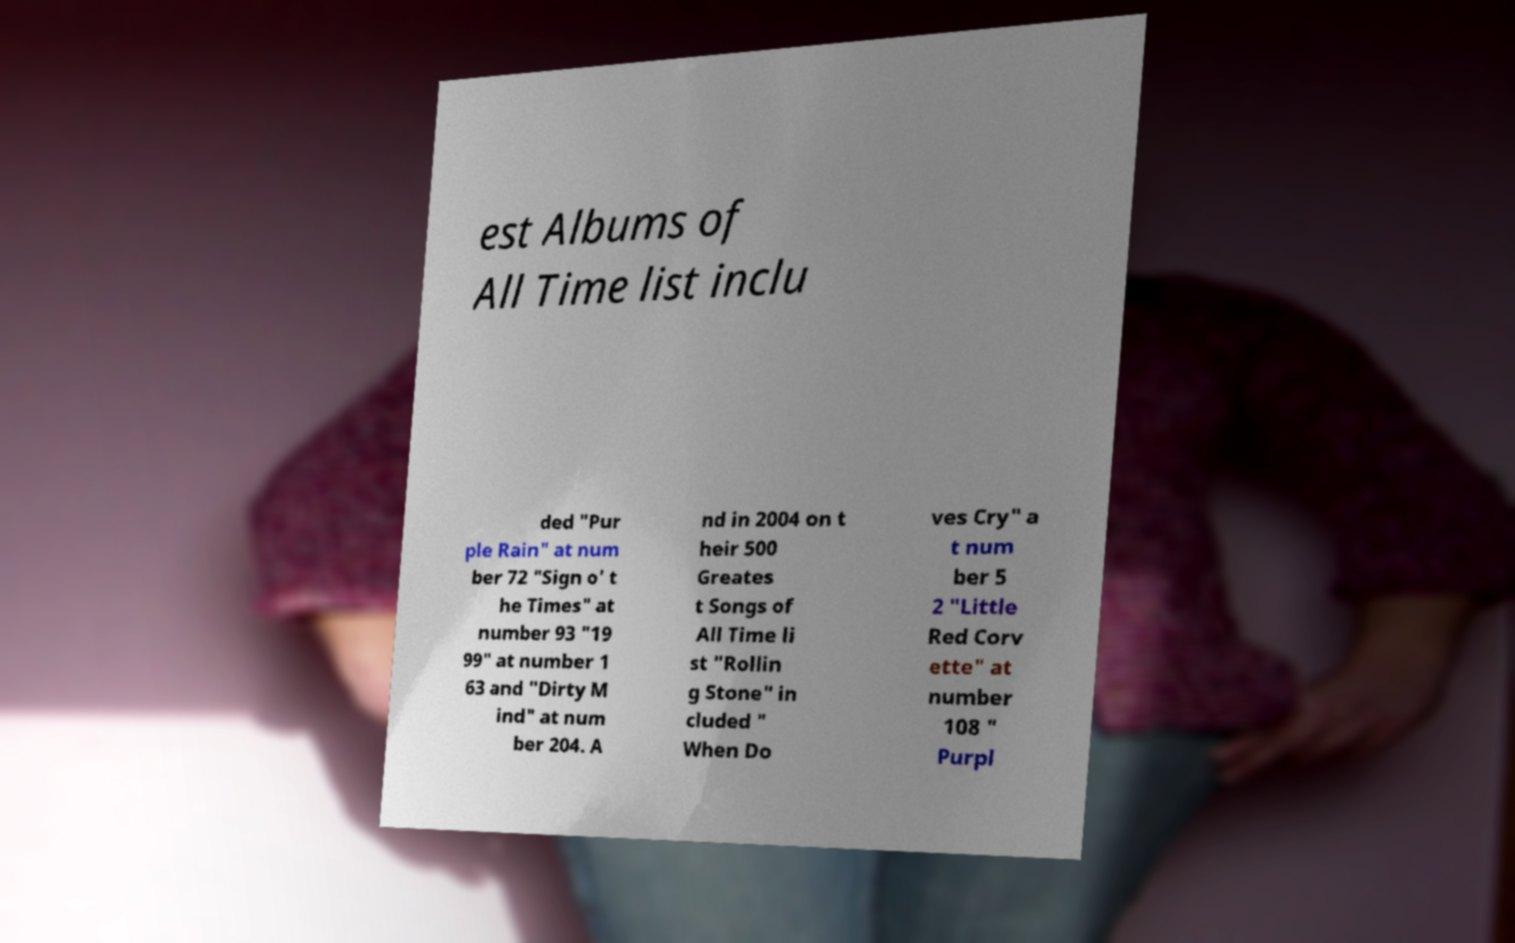For documentation purposes, I need the text within this image transcribed. Could you provide that? est Albums of All Time list inclu ded "Pur ple Rain" at num ber 72 "Sign o' t he Times" at number 93 "19 99" at number 1 63 and "Dirty M ind" at num ber 204. A nd in 2004 on t heir 500 Greates t Songs of All Time li st "Rollin g Stone" in cluded " When Do ves Cry" a t num ber 5 2 "Little Red Corv ette" at number 108 " Purpl 